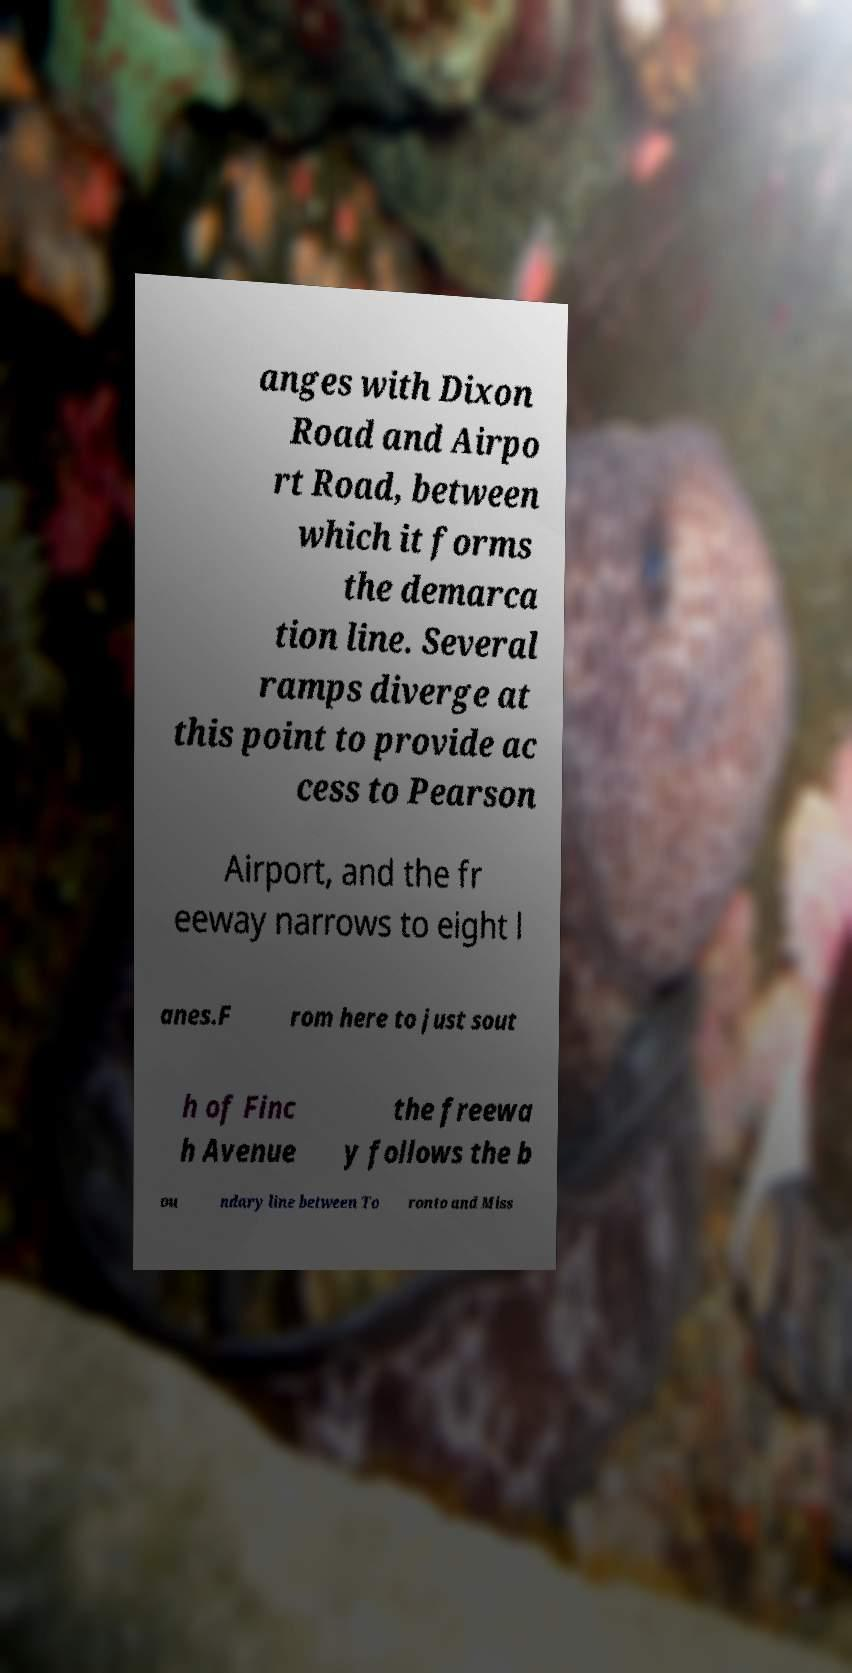Can you accurately transcribe the text from the provided image for me? anges with Dixon Road and Airpo rt Road, between which it forms the demarca tion line. Several ramps diverge at this point to provide ac cess to Pearson Airport, and the fr eeway narrows to eight l anes.F rom here to just sout h of Finc h Avenue the freewa y follows the b ou ndary line between To ronto and Miss 